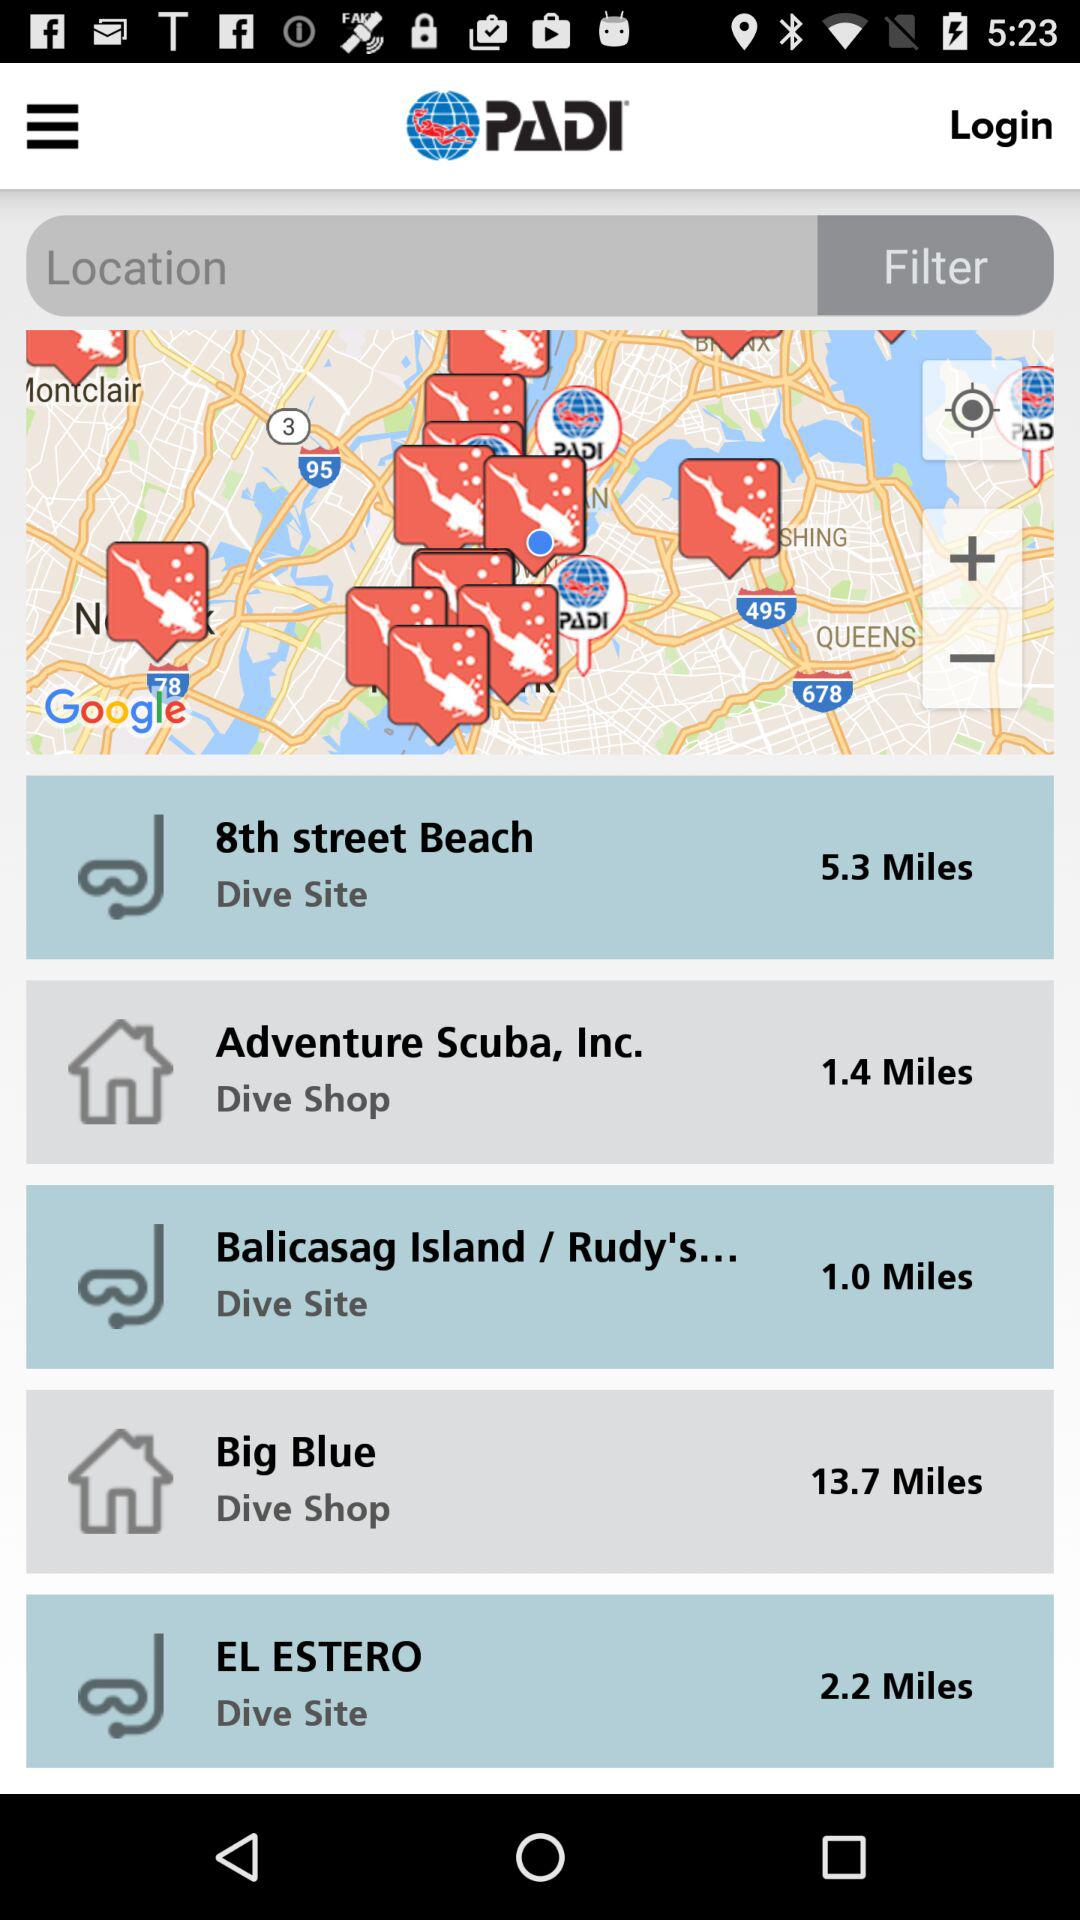Which place is at a distance of 1.4 miles? The place that is at a distance of 1.4 miles is "Adventure Scuba, Inc.". 